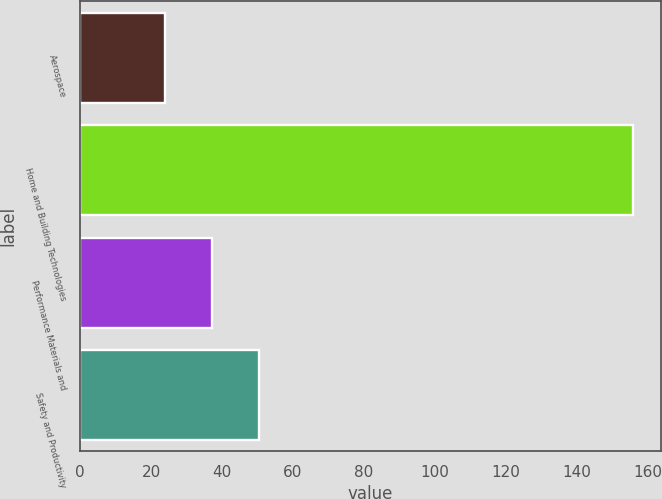<chart> <loc_0><loc_0><loc_500><loc_500><bar_chart><fcel>Aerospace<fcel>Home and Building Technologies<fcel>Performance Materials and<fcel>Safety and Productivity<nl><fcel>24<fcel>156<fcel>37.2<fcel>50.4<nl></chart> 